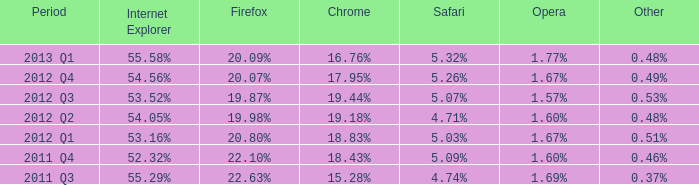What opera has 19.87% as the firefox? 1.57%. 